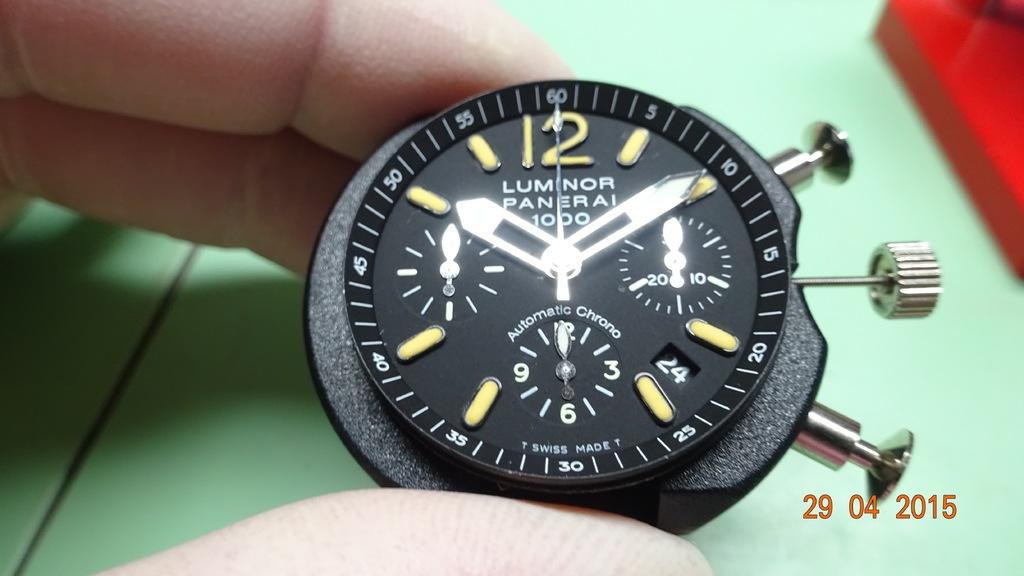What time is it?
Make the answer very short. 10:10. What brand watch is this?
Keep it short and to the point. Luminor. 